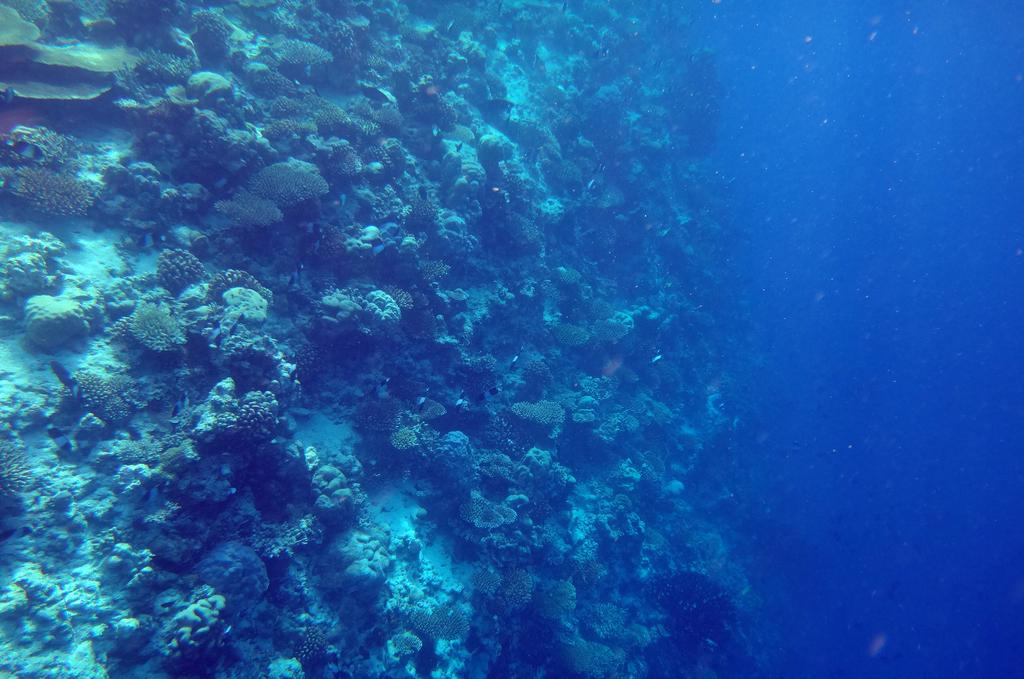What type of environment is depicted in the image? The image is an inside view of an ocean. What type of vegetation can be seen in the image? There are water plants in the image. What is the primary element visible in the image? Water is visible in the image. Can you see any footprints in the image? There are no footprints visible in the image, as it is an inside view of an ocean. What type of flesh can be seen in the image? There is no flesh present in the image, as it is an inside view of an ocean. 